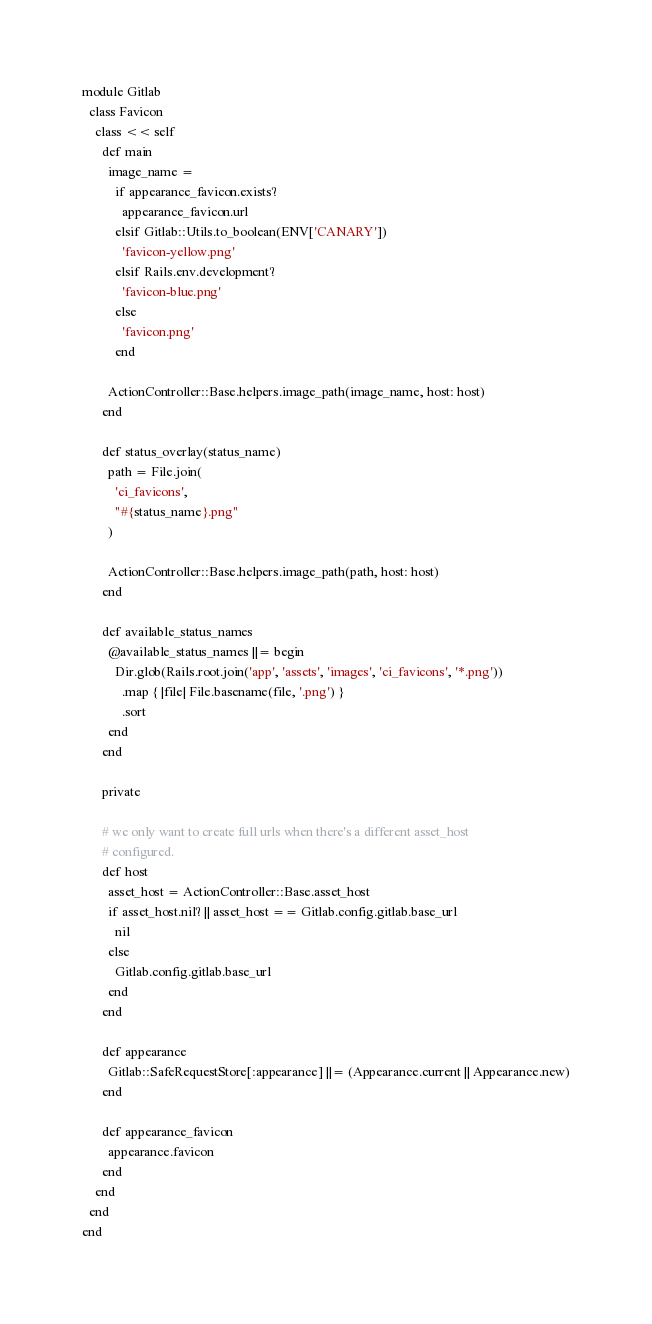Convert code to text. <code><loc_0><loc_0><loc_500><loc_500><_Ruby_>
module Gitlab
  class Favicon
    class << self
      def main
        image_name =
          if appearance_favicon.exists?
            appearance_favicon.url
          elsif Gitlab::Utils.to_boolean(ENV['CANARY'])
            'favicon-yellow.png'
          elsif Rails.env.development?
            'favicon-blue.png'
          else
            'favicon.png'
          end

        ActionController::Base.helpers.image_path(image_name, host: host)
      end

      def status_overlay(status_name)
        path = File.join(
          'ci_favicons',
          "#{status_name}.png"
        )

        ActionController::Base.helpers.image_path(path, host: host)
      end

      def available_status_names
        @available_status_names ||= begin
          Dir.glob(Rails.root.join('app', 'assets', 'images', 'ci_favicons', '*.png'))
            .map { |file| File.basename(file, '.png') }
            .sort
        end
      end

      private

      # we only want to create full urls when there's a different asset_host
      # configured.
      def host
        asset_host = ActionController::Base.asset_host
        if asset_host.nil? || asset_host == Gitlab.config.gitlab.base_url
          nil
        else
          Gitlab.config.gitlab.base_url
        end
      end

      def appearance
        Gitlab::SafeRequestStore[:appearance] ||= (Appearance.current || Appearance.new)
      end

      def appearance_favicon
        appearance.favicon
      end
    end
  end
end
</code> 